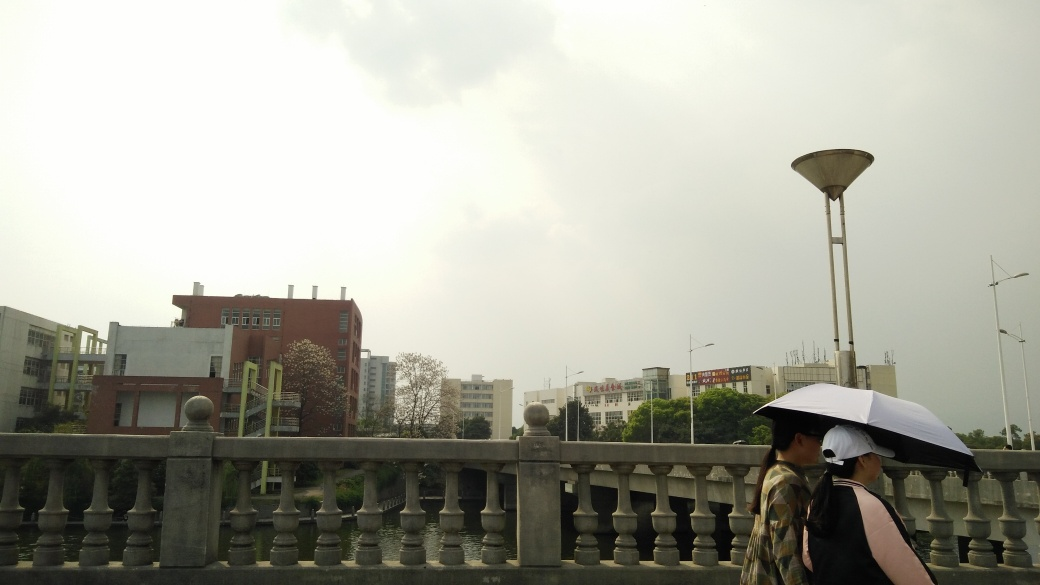Are there two people walking with umbrellas?
 Yes 